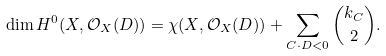Convert formula to latex. <formula><loc_0><loc_0><loc_500><loc_500>\dim H ^ { 0 } ( X , \mathcal { O } _ { X } ( D ) ) = \chi ( X , \mathcal { O } _ { X } ( D ) ) + \sum _ { C \cdot D < 0 } \binom { k _ { C } } { 2 } .</formula> 